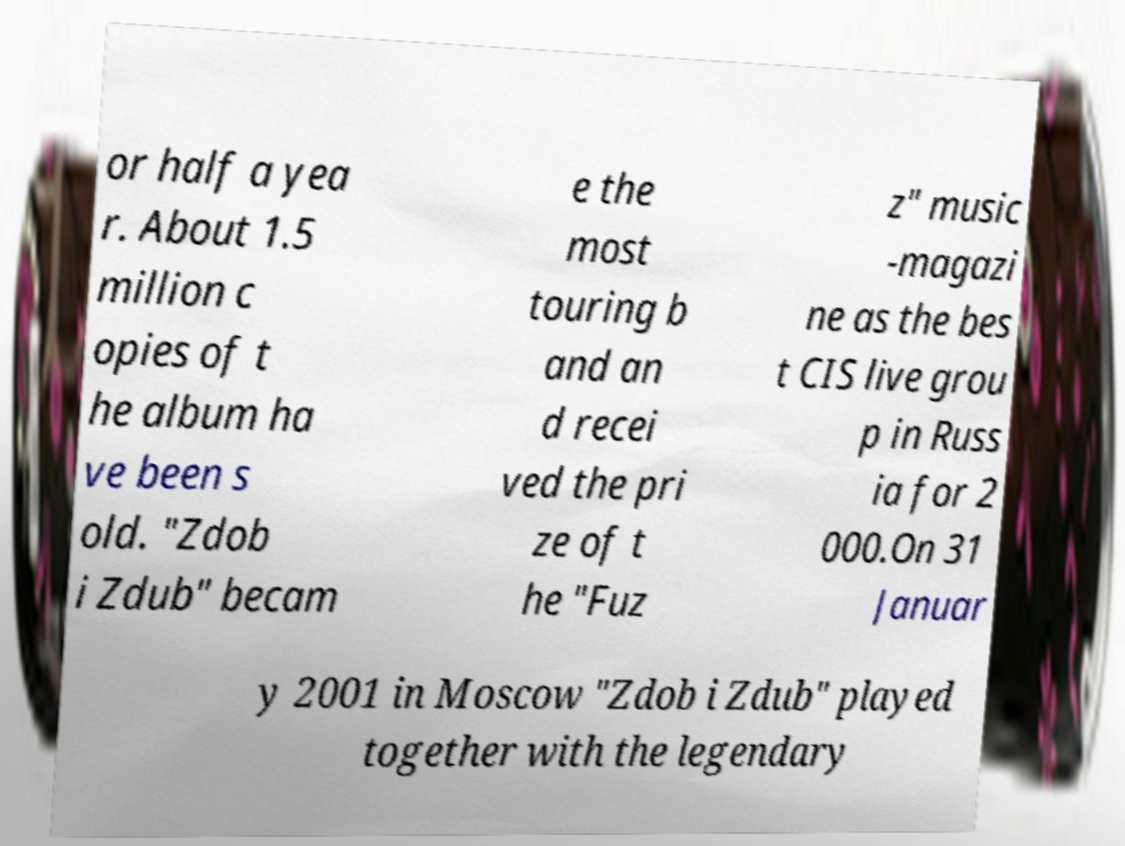There's text embedded in this image that I need extracted. Can you transcribe it verbatim? or half a yea r. About 1.5 million c opies of t he album ha ve been s old. "Zdob i Zdub" becam e the most touring b and an d recei ved the pri ze of t he "Fuz z" music -magazi ne as the bes t CIS live grou p in Russ ia for 2 000.On 31 Januar y 2001 in Moscow "Zdob i Zdub" played together with the legendary 